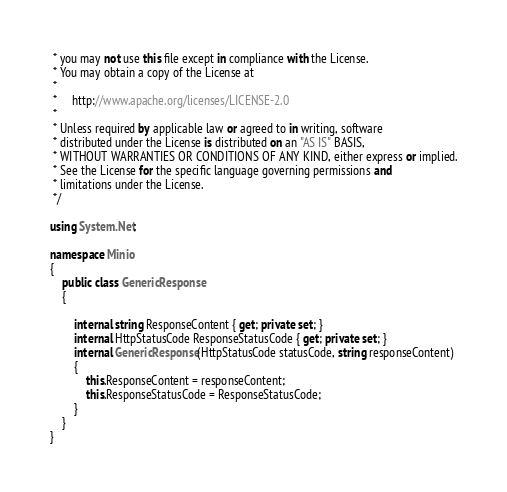Convert code to text. <code><loc_0><loc_0><loc_500><loc_500><_C#_> * you may not use this file except in compliance with the License.
 * You may obtain a copy of the License at
 *
 *     http://www.apache.org/licenses/LICENSE-2.0
 *
 * Unless required by applicable law or agreed to in writing, software
 * distributed under the License is distributed on an "AS IS" BASIS,
 * WITHOUT WARRANTIES OR CONDITIONS OF ANY KIND, either express or implied.
 * See the License for the specific language governing permissions and
 * limitations under the License.
 */

using System.Net;

namespace Minio
{
    public class GenericResponse
    {

        internal string ResponseContent { get; private set; }
        internal HttpStatusCode ResponseStatusCode { get; private set; }
        internal GenericResponse(HttpStatusCode statusCode, string responseContent)
        {
            this.ResponseContent = responseContent;
            this.ResponseStatusCode = ResponseStatusCode;
        }
    }
}</code> 